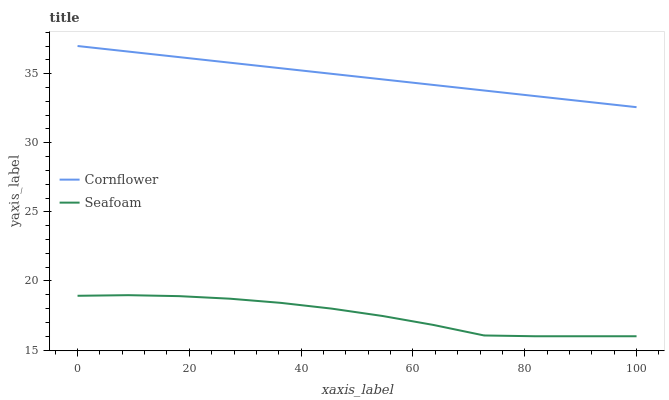Does Seafoam have the minimum area under the curve?
Answer yes or no. Yes. Does Cornflower have the maximum area under the curve?
Answer yes or no. Yes. Does Seafoam have the maximum area under the curve?
Answer yes or no. No. Is Cornflower the smoothest?
Answer yes or no. Yes. Is Seafoam the roughest?
Answer yes or no. Yes. Is Seafoam the smoothest?
Answer yes or no. No. Does Seafoam have the lowest value?
Answer yes or no. Yes. Does Cornflower have the highest value?
Answer yes or no. Yes. Does Seafoam have the highest value?
Answer yes or no. No. Is Seafoam less than Cornflower?
Answer yes or no. Yes. Is Cornflower greater than Seafoam?
Answer yes or no. Yes. Does Seafoam intersect Cornflower?
Answer yes or no. No. 